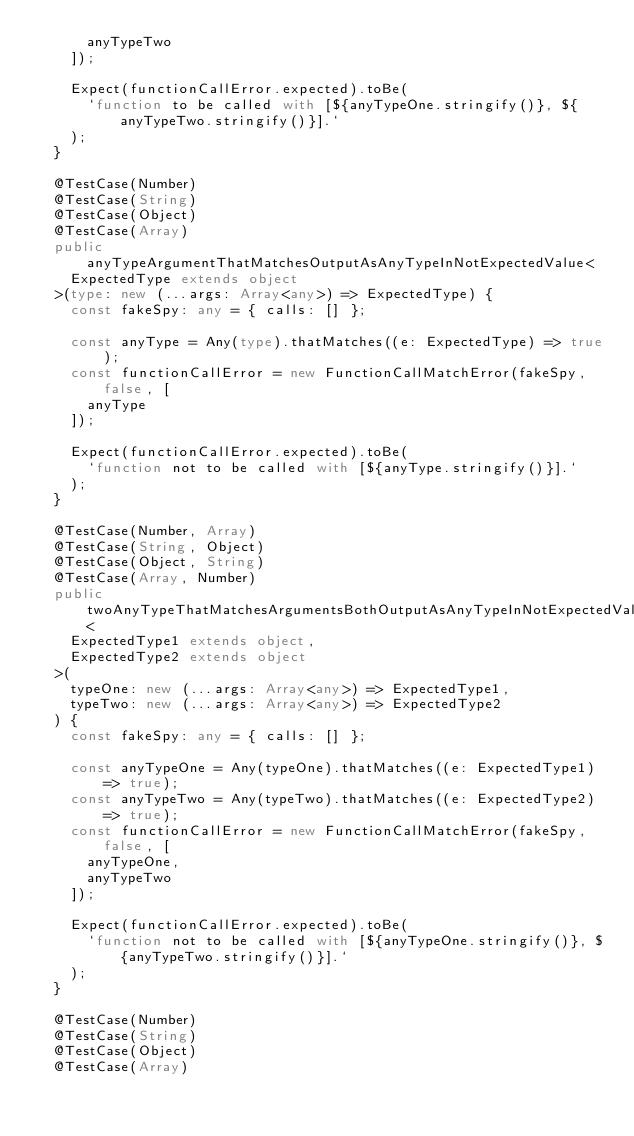Convert code to text. <code><loc_0><loc_0><loc_500><loc_500><_TypeScript_>      anyTypeTwo
    ]);

    Expect(functionCallError.expected).toBe(
      `function to be called with [${anyTypeOne.stringify()}, ${anyTypeTwo.stringify()}].`
    );
  }

  @TestCase(Number)
  @TestCase(String)
  @TestCase(Object)
  @TestCase(Array)
  public anyTypeArgumentThatMatchesOutputAsAnyTypeInNotExpectedValue<
    ExpectedType extends object
  >(type: new (...args: Array<any>) => ExpectedType) {
    const fakeSpy: any = { calls: [] };

    const anyType = Any(type).thatMatches((e: ExpectedType) => true);
    const functionCallError = new FunctionCallMatchError(fakeSpy, false, [
      anyType
    ]);

    Expect(functionCallError.expected).toBe(
      `function not to be called with [${anyType.stringify()}].`
    );
  }

  @TestCase(Number, Array)
  @TestCase(String, Object)
  @TestCase(Object, String)
  @TestCase(Array, Number)
  public twoAnyTypeThatMatchesArgumentsBothOutputAsAnyTypeInNotExpectedValue<
    ExpectedType1 extends object,
    ExpectedType2 extends object
  >(
    typeOne: new (...args: Array<any>) => ExpectedType1,
    typeTwo: new (...args: Array<any>) => ExpectedType2
  ) {
    const fakeSpy: any = { calls: [] };

    const anyTypeOne = Any(typeOne).thatMatches((e: ExpectedType1) => true);
    const anyTypeTwo = Any(typeTwo).thatMatches((e: ExpectedType2) => true);
    const functionCallError = new FunctionCallMatchError(fakeSpy, false, [
      anyTypeOne,
      anyTypeTwo
    ]);

    Expect(functionCallError.expected).toBe(
      `function not to be called with [${anyTypeOne.stringify()}, ${anyTypeTwo.stringify()}].`
    );
  }

  @TestCase(Number)
  @TestCase(String)
  @TestCase(Object)
  @TestCase(Array)</code> 